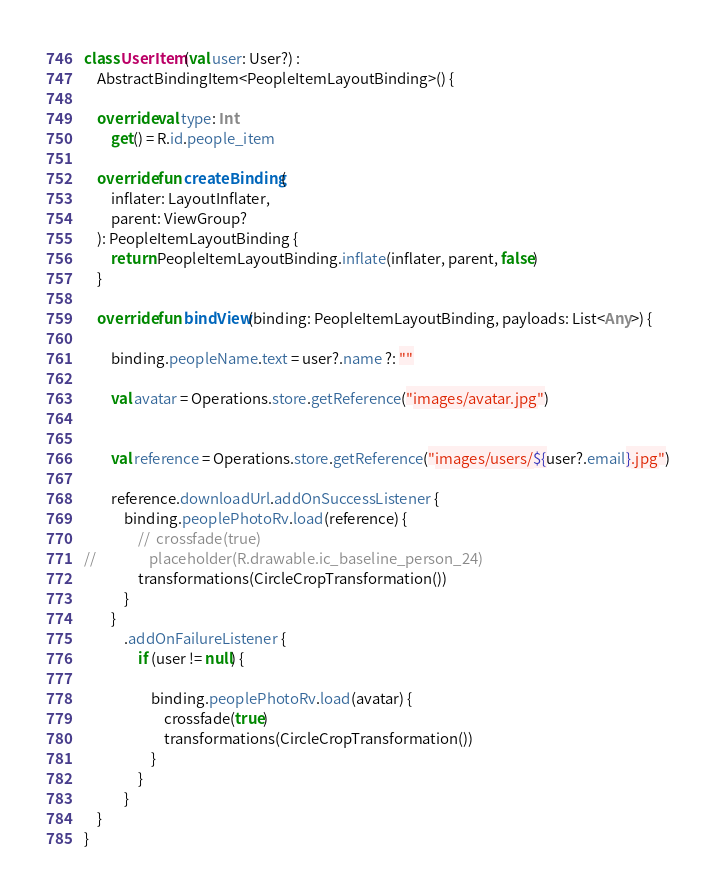Convert code to text. <code><loc_0><loc_0><loc_500><loc_500><_Kotlin_>
class UserItem(val user: User?) :
    AbstractBindingItem<PeopleItemLayoutBinding>() {

    override val type: Int
        get() = R.id.people_item

    override fun createBinding(
        inflater: LayoutInflater,
        parent: ViewGroup?
    ): PeopleItemLayoutBinding {
        return PeopleItemLayoutBinding.inflate(inflater, parent, false)
    }

    override fun bindView(binding: PeopleItemLayoutBinding, payloads: List<Any>) {

        binding.peopleName.text = user?.name ?: ""

        val avatar = Operations.store.getReference("images/avatar.jpg")


        val reference = Operations.store.getReference("images/users/${user?.email}.jpg")

        reference.downloadUrl.addOnSuccessListener {
            binding.peoplePhotoRv.load(reference) {
                //  crossfade(true)
//                placeholder(R.drawable.ic_baseline_person_24)
                transformations(CircleCropTransformation())
            }
        }
            .addOnFailureListener {
                if (user != null) {

                    binding.peoplePhotoRv.load(avatar) {
                        crossfade(true)
                        transformations(CircleCropTransformation())
                    }
                }
            }
    }
}
</code> 